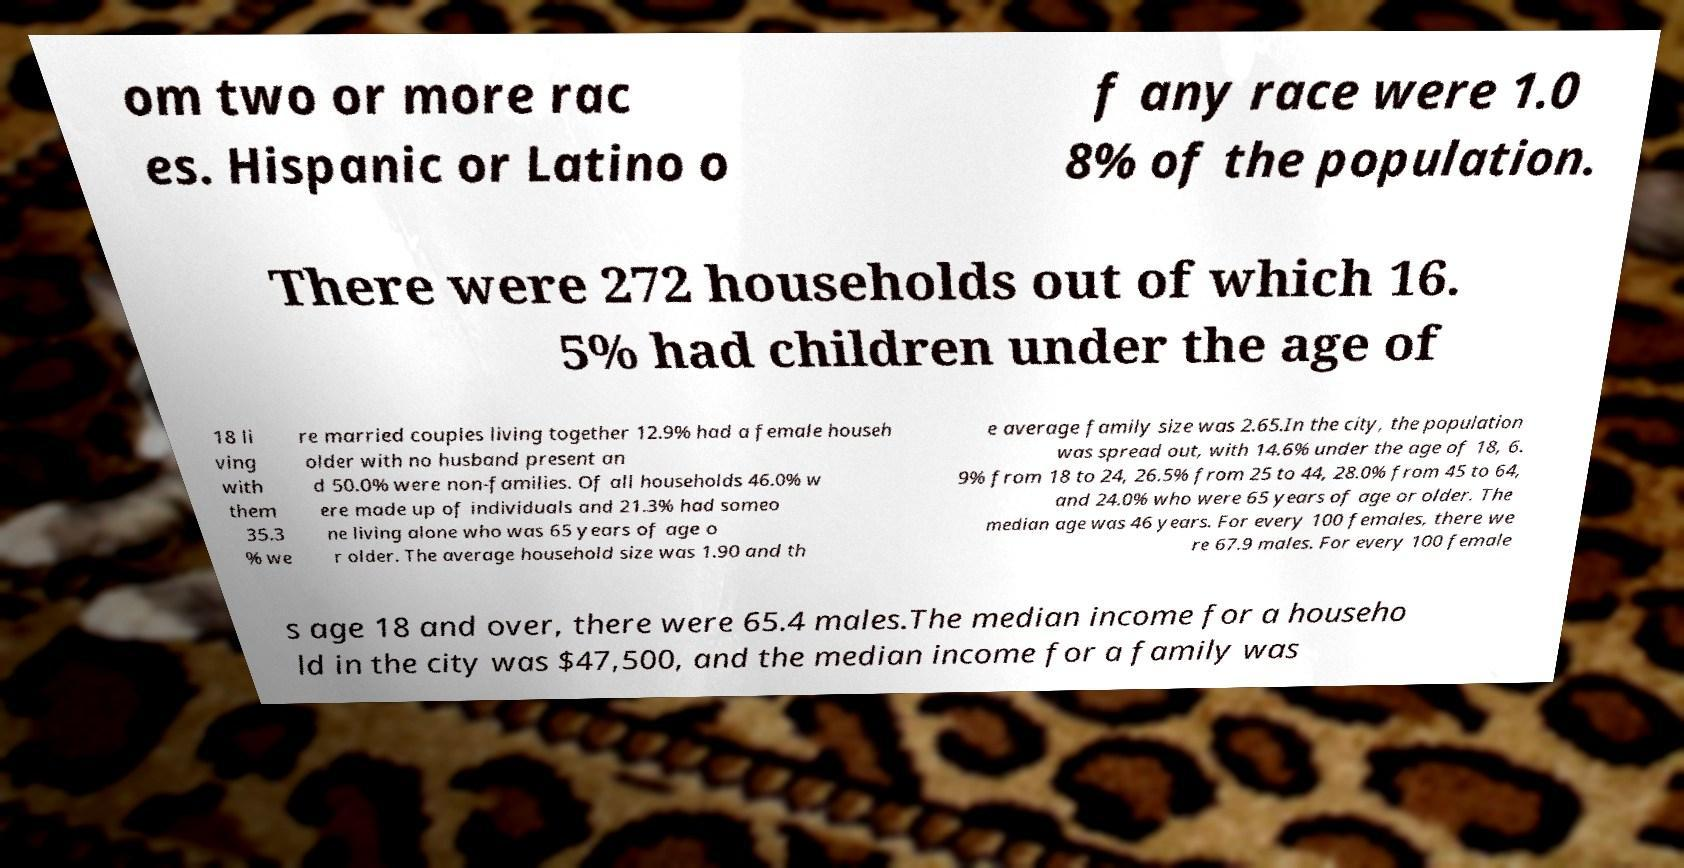Can you accurately transcribe the text from the provided image for me? om two or more rac es. Hispanic or Latino o f any race were 1.0 8% of the population. There were 272 households out of which 16. 5% had children under the age of 18 li ving with them 35.3 % we re married couples living together 12.9% had a female househ older with no husband present an d 50.0% were non-families. Of all households 46.0% w ere made up of individuals and 21.3% had someo ne living alone who was 65 years of age o r older. The average household size was 1.90 and th e average family size was 2.65.In the city, the population was spread out, with 14.6% under the age of 18, 6. 9% from 18 to 24, 26.5% from 25 to 44, 28.0% from 45 to 64, and 24.0% who were 65 years of age or older. The median age was 46 years. For every 100 females, there we re 67.9 males. For every 100 female s age 18 and over, there were 65.4 males.The median income for a househo ld in the city was $47,500, and the median income for a family was 